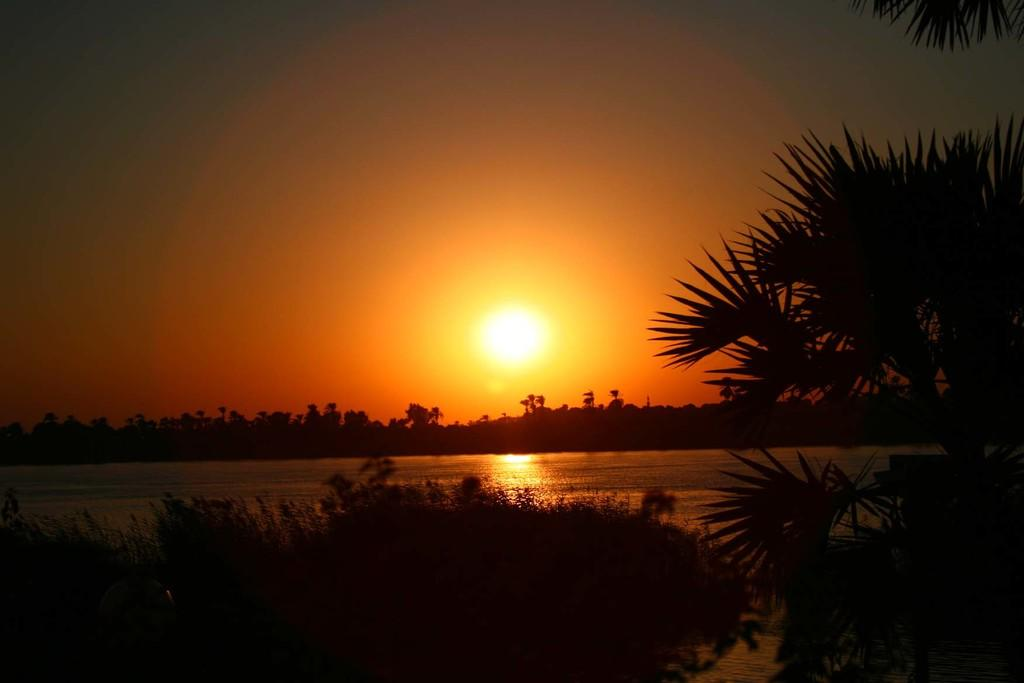What type of vegetation can be seen in the image? There are plants and trees visible in the image. What natural element is present in the image? There is water visible in the image. What is visible in the background of the image? The sky is visible in the image. Can the sun be seen in the image? Yes, the sun is observable in the sky. What type of mist can be seen covering the land in the image? There is no mist present in the image; it features plants, trees, water, sky, and the sun. What part of the land is visible in the image? The image does not focus on a specific part of the land; it shows a broader view of the natural environment. 